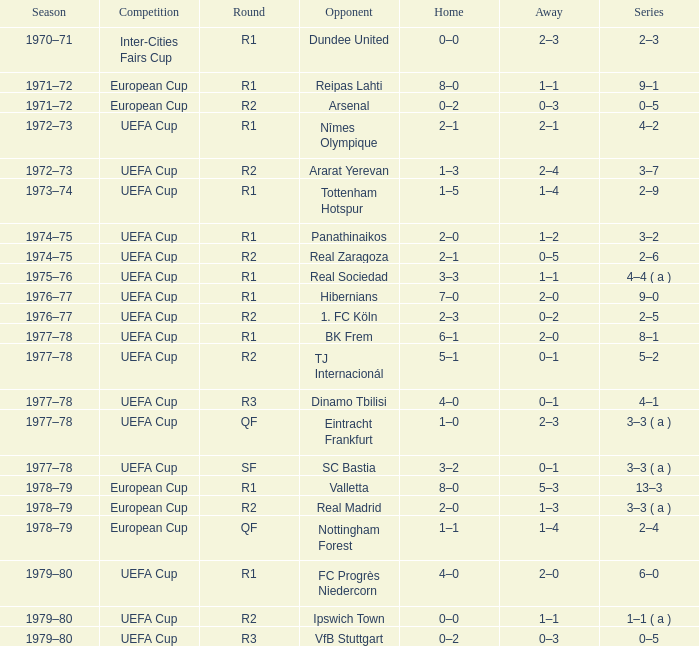In which series is there a 2-0 home advantage and an adversary named panathinaikos? 3–2. 